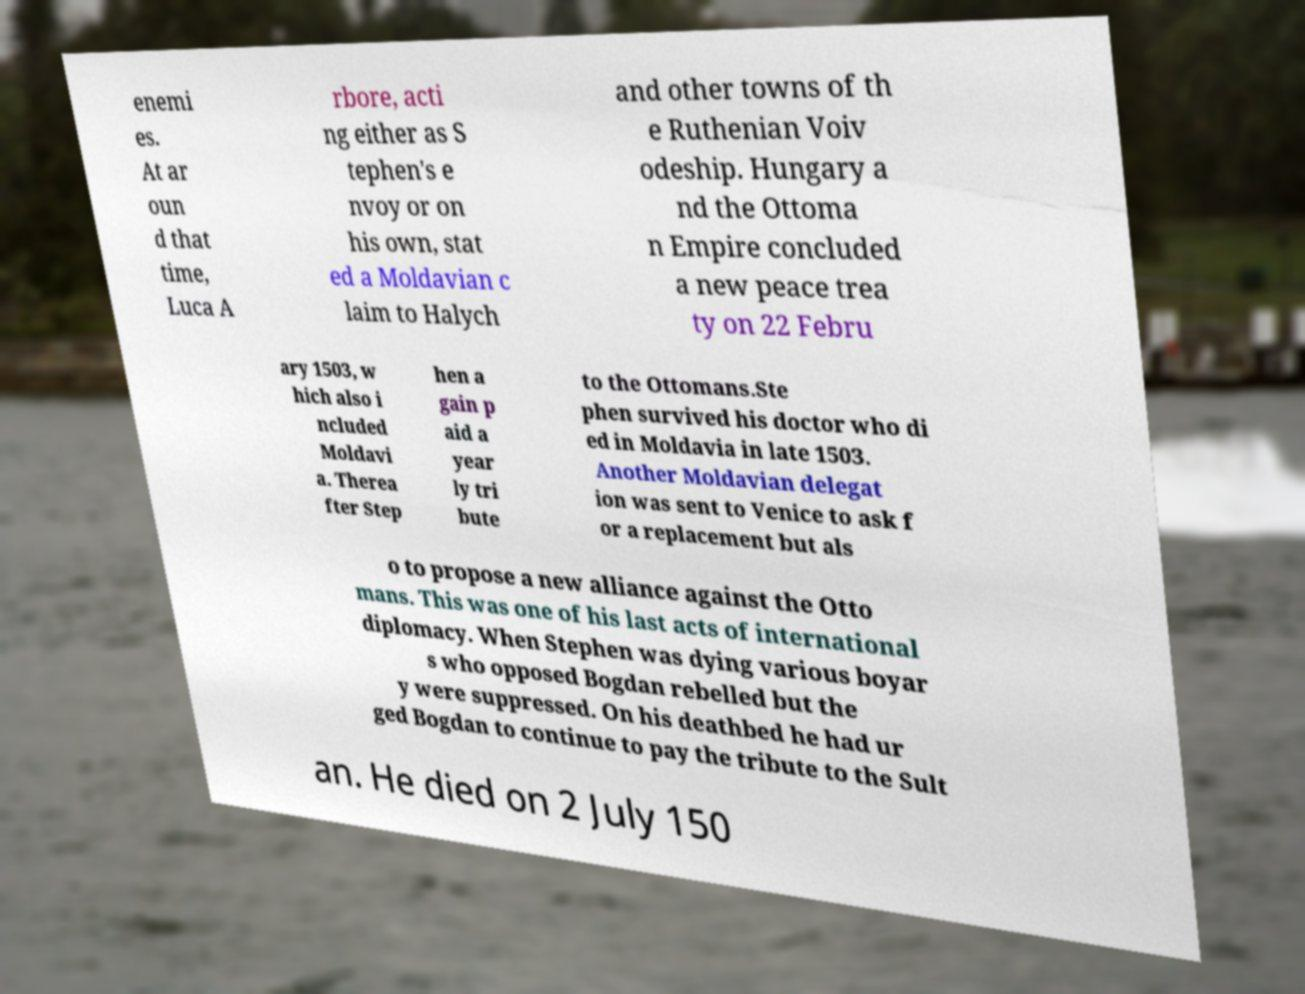There's text embedded in this image that I need extracted. Can you transcribe it verbatim? enemi es. At ar oun d that time, Luca A rbore, acti ng either as S tephen's e nvoy or on his own, stat ed a Moldavian c laim to Halych and other towns of th e Ruthenian Voiv odeship. Hungary a nd the Ottoma n Empire concluded a new peace trea ty on 22 Febru ary 1503, w hich also i ncluded Moldavi a. Therea fter Step hen a gain p aid a year ly tri bute to the Ottomans.Ste phen survived his doctor who di ed in Moldavia in late 1503. Another Moldavian delegat ion was sent to Venice to ask f or a replacement but als o to propose a new alliance against the Otto mans. This was one of his last acts of international diplomacy. When Stephen was dying various boyar s who opposed Bogdan rebelled but the y were suppressed. On his deathbed he had ur ged Bogdan to continue to pay the tribute to the Sult an. He died on 2 July 150 